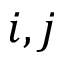<formula> <loc_0><loc_0><loc_500><loc_500>i , j</formula> 